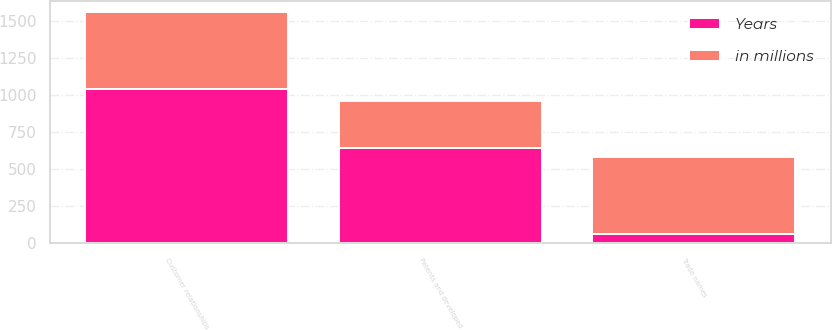<chart> <loc_0><loc_0><loc_500><loc_500><stacked_bar_chart><ecel><fcel>Patents and developed<fcel>Customer relationships<fcel>Trade names<nl><fcel>in millions<fcel>315<fcel>514<fcel>520<nl><fcel>Years<fcel>647<fcel>1046<fcel>66<nl></chart> 